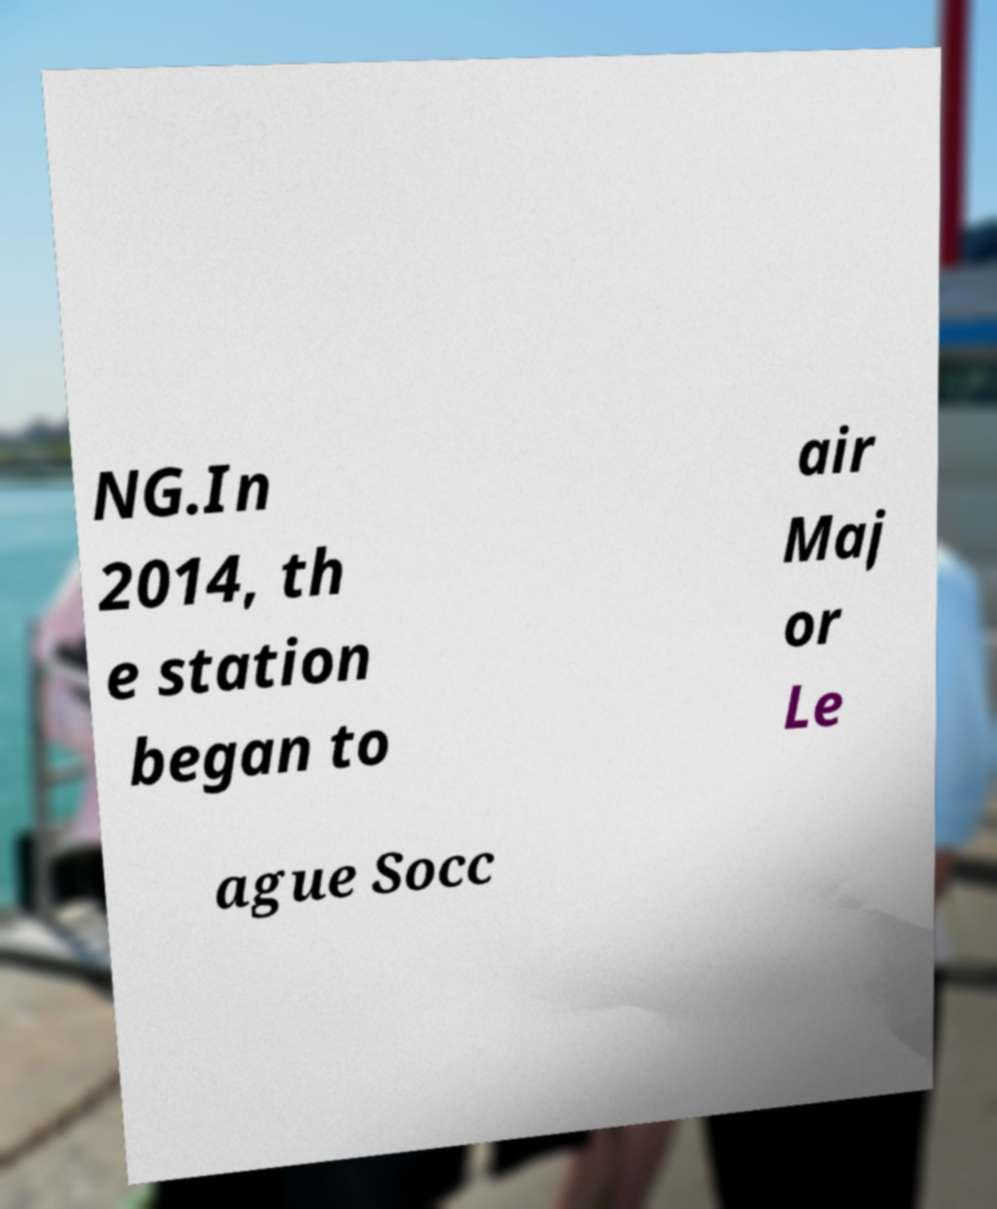I need the written content from this picture converted into text. Can you do that? NG.In 2014, th e station began to air Maj or Le ague Socc 